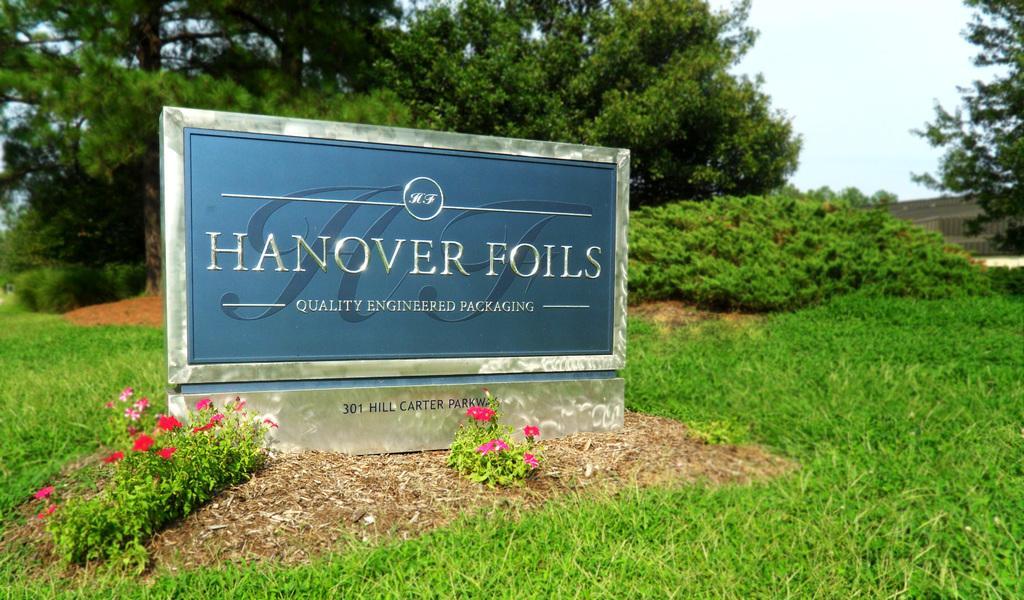Could you give a brief overview of what you see in this image? In this picture we can see a name board, flowers, grass, trees and in the background we can see the sky. 